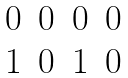Convert formula to latex. <formula><loc_0><loc_0><loc_500><loc_500>\begin{matrix} 0 & 0 & 0 & 0 \\ 1 & 0 & 1 & 0 \end{matrix}</formula> 